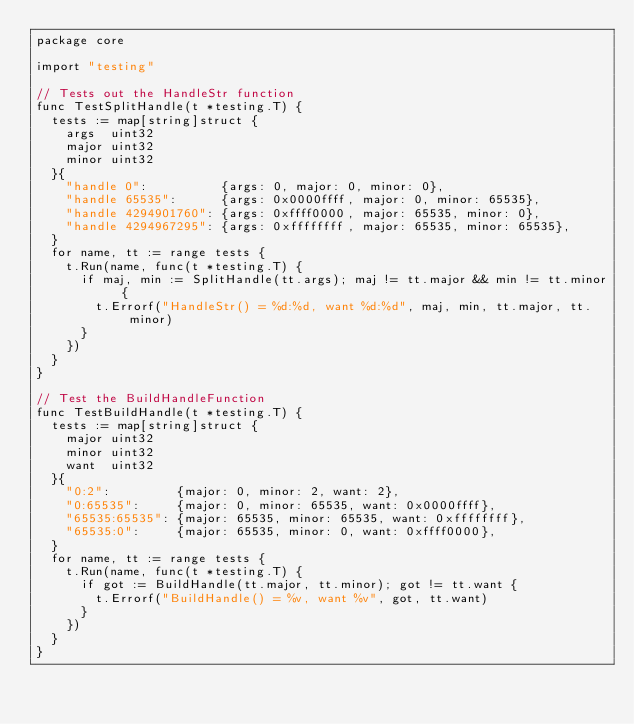Convert code to text. <code><loc_0><loc_0><loc_500><loc_500><_Go_>package core

import "testing"

// Tests out the HandleStr function
func TestSplitHandle(t *testing.T) {
	tests := map[string]struct {
		args  uint32
		major uint32
		minor uint32
	}{
		"handle 0":          {args: 0, major: 0, minor: 0},
		"handle 65535":      {args: 0x0000ffff, major: 0, minor: 65535},
		"handle 4294901760": {args: 0xffff0000, major: 65535, minor: 0},
		"handle 4294967295": {args: 0xffffffff, major: 65535, minor: 65535},
	}
	for name, tt := range tests {
		t.Run(name, func(t *testing.T) {
			if maj, min := SplitHandle(tt.args); maj != tt.major && min != tt.minor {
				t.Errorf("HandleStr() = %d:%d, want %d:%d", maj, min, tt.major, tt.minor)
			}
		})
	}
}

// Test the BuildHandleFunction
func TestBuildHandle(t *testing.T) {
	tests := map[string]struct {
		major uint32
		minor uint32
		want  uint32
	}{
		"0:2":         {major: 0, minor: 2, want: 2},
		"0:65535":     {major: 0, minor: 65535, want: 0x0000ffff},
		"65535:65535": {major: 65535, minor: 65535, want: 0xffffffff},
		"65535:0":     {major: 65535, minor: 0, want: 0xffff0000},
	}
	for name, tt := range tests {
		t.Run(name, func(t *testing.T) {
			if got := BuildHandle(tt.major, tt.minor); got != tt.want {
				t.Errorf("BuildHandle() = %v, want %v", got, tt.want)
			}
		})
	}
}
</code> 